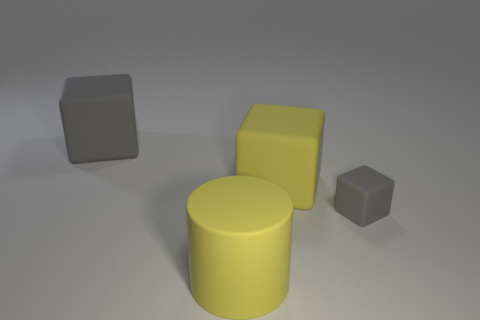There is another matte cube that is the same size as the yellow block; what is its color?
Your answer should be very brief. Gray. What is the large block on the left side of the yellow cylinder made of?
Make the answer very short. Rubber. What is the material of the thing that is both left of the small gray matte cube and in front of the large yellow rubber cube?
Provide a succinct answer. Rubber. There is a matte block left of the yellow rubber cylinder; does it have the same size as the small rubber thing?
Ensure brevity in your answer.  No. How many other small blue matte objects are the same shape as the small thing?
Offer a very short reply. 0. What number of matte objects are both in front of the large gray cube and left of the yellow cylinder?
Your answer should be compact. 0. The big matte cylinder is what color?
Ensure brevity in your answer.  Yellow. Is there a tiny gray block made of the same material as the big yellow cylinder?
Your answer should be compact. Yes. Are there any large yellow matte blocks in front of the large matte thing that is behind the big thing that is right of the big cylinder?
Provide a succinct answer. Yes. There is a large gray thing; are there any big matte objects in front of it?
Keep it short and to the point. Yes. 